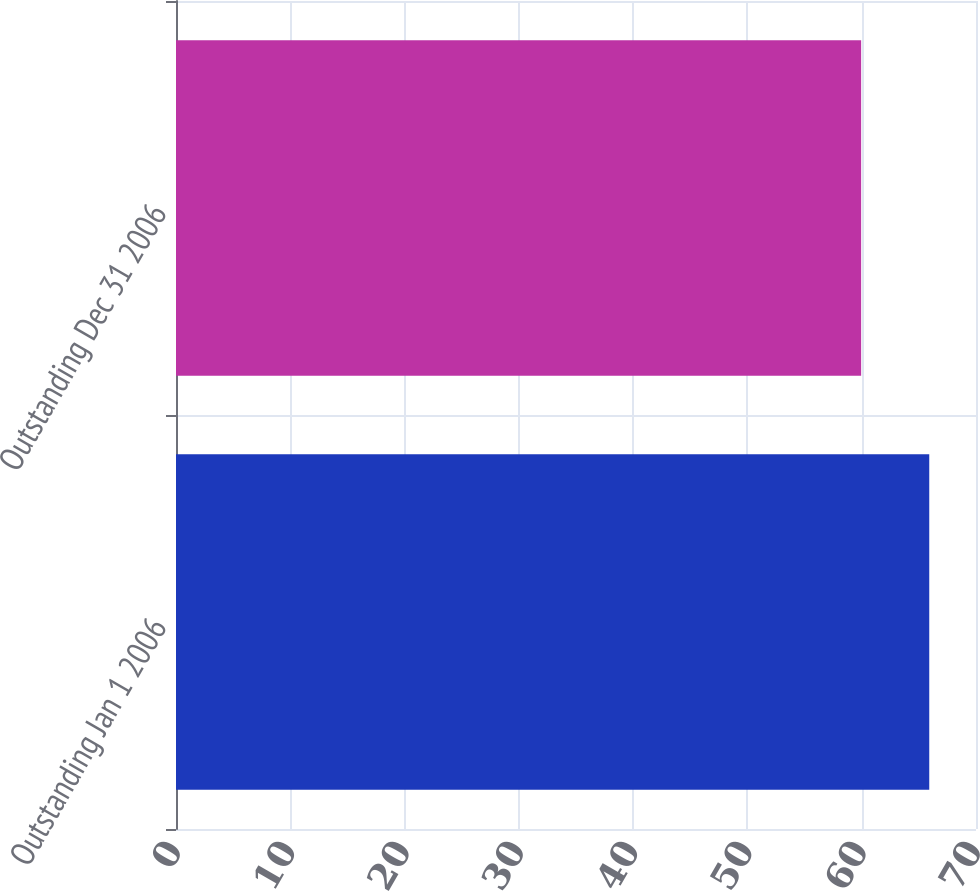Convert chart. <chart><loc_0><loc_0><loc_500><loc_500><bar_chart><fcel>Outstanding Jan 1 2006<fcel>Outstanding Dec 31 2006<nl><fcel>65.91<fcel>59.95<nl></chart> 